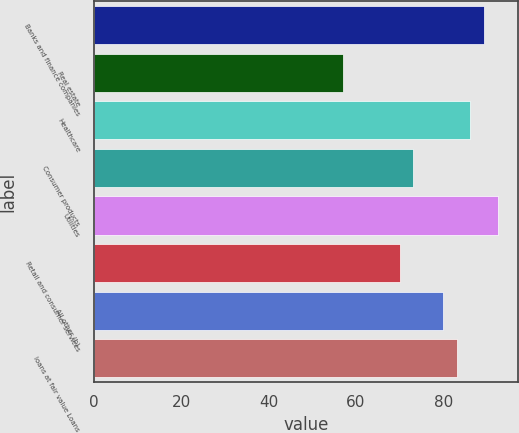<chart> <loc_0><loc_0><loc_500><loc_500><bar_chart><fcel>Banks and finance companies<fcel>Real estate<fcel>Healthcare<fcel>Consumer products<fcel>Utilities<fcel>Retail and consumer services<fcel>All other (b)<fcel>loans at fair value Loans<nl><fcel>89.3<fcel>57<fcel>86.2<fcel>73.1<fcel>92.4<fcel>70<fcel>80<fcel>83.1<nl></chart> 